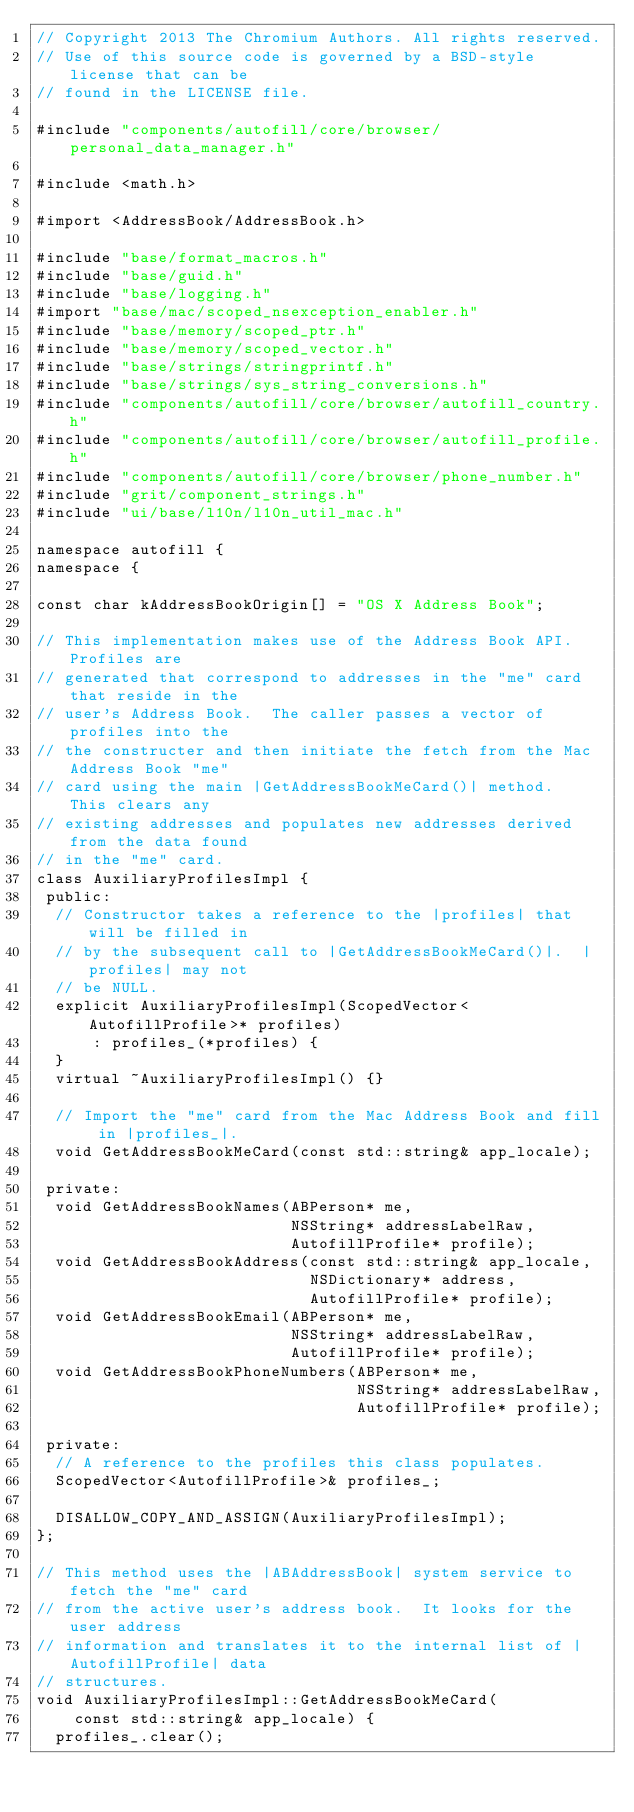Convert code to text. <code><loc_0><loc_0><loc_500><loc_500><_ObjectiveC_>// Copyright 2013 The Chromium Authors. All rights reserved.
// Use of this source code is governed by a BSD-style license that can be
// found in the LICENSE file.

#include "components/autofill/core/browser/personal_data_manager.h"

#include <math.h>

#import <AddressBook/AddressBook.h>

#include "base/format_macros.h"
#include "base/guid.h"
#include "base/logging.h"
#import "base/mac/scoped_nsexception_enabler.h"
#include "base/memory/scoped_ptr.h"
#include "base/memory/scoped_vector.h"
#include "base/strings/stringprintf.h"
#include "base/strings/sys_string_conversions.h"
#include "components/autofill/core/browser/autofill_country.h"
#include "components/autofill/core/browser/autofill_profile.h"
#include "components/autofill/core/browser/phone_number.h"
#include "grit/component_strings.h"
#include "ui/base/l10n/l10n_util_mac.h"

namespace autofill {
namespace {

const char kAddressBookOrigin[] = "OS X Address Book";

// This implementation makes use of the Address Book API.  Profiles are
// generated that correspond to addresses in the "me" card that reside in the
// user's Address Book.  The caller passes a vector of profiles into the
// the constructer and then initiate the fetch from the Mac Address Book "me"
// card using the main |GetAddressBookMeCard()| method.  This clears any
// existing addresses and populates new addresses derived from the data found
// in the "me" card.
class AuxiliaryProfilesImpl {
 public:
  // Constructor takes a reference to the |profiles| that will be filled in
  // by the subsequent call to |GetAddressBookMeCard()|.  |profiles| may not
  // be NULL.
  explicit AuxiliaryProfilesImpl(ScopedVector<AutofillProfile>* profiles)
      : profiles_(*profiles) {
  }
  virtual ~AuxiliaryProfilesImpl() {}

  // Import the "me" card from the Mac Address Book and fill in |profiles_|.
  void GetAddressBookMeCard(const std::string& app_locale);

 private:
  void GetAddressBookNames(ABPerson* me,
                           NSString* addressLabelRaw,
                           AutofillProfile* profile);
  void GetAddressBookAddress(const std::string& app_locale,
                             NSDictionary* address,
                             AutofillProfile* profile);
  void GetAddressBookEmail(ABPerson* me,
                           NSString* addressLabelRaw,
                           AutofillProfile* profile);
  void GetAddressBookPhoneNumbers(ABPerson* me,
                                  NSString* addressLabelRaw,
                                  AutofillProfile* profile);

 private:
  // A reference to the profiles this class populates.
  ScopedVector<AutofillProfile>& profiles_;

  DISALLOW_COPY_AND_ASSIGN(AuxiliaryProfilesImpl);
};

// This method uses the |ABAddressBook| system service to fetch the "me" card
// from the active user's address book.  It looks for the user address
// information and translates it to the internal list of |AutofillProfile| data
// structures.
void AuxiliaryProfilesImpl::GetAddressBookMeCard(
    const std::string& app_locale) {
  profiles_.clear();
</code> 